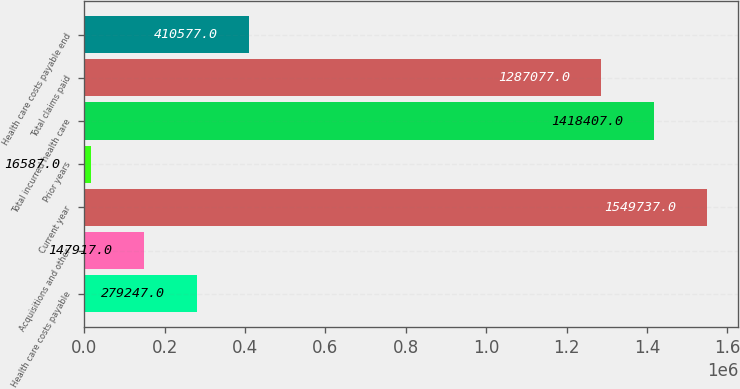Convert chart to OTSL. <chart><loc_0><loc_0><loc_500><loc_500><bar_chart><fcel>Health care costs payable<fcel>Acquisitions and other<fcel>Current year<fcel>Prior years<fcel>Total incurred health care<fcel>Total claims paid<fcel>Health care costs payable end<nl><fcel>279247<fcel>147917<fcel>1.54974e+06<fcel>16587<fcel>1.41841e+06<fcel>1.28708e+06<fcel>410577<nl></chart> 